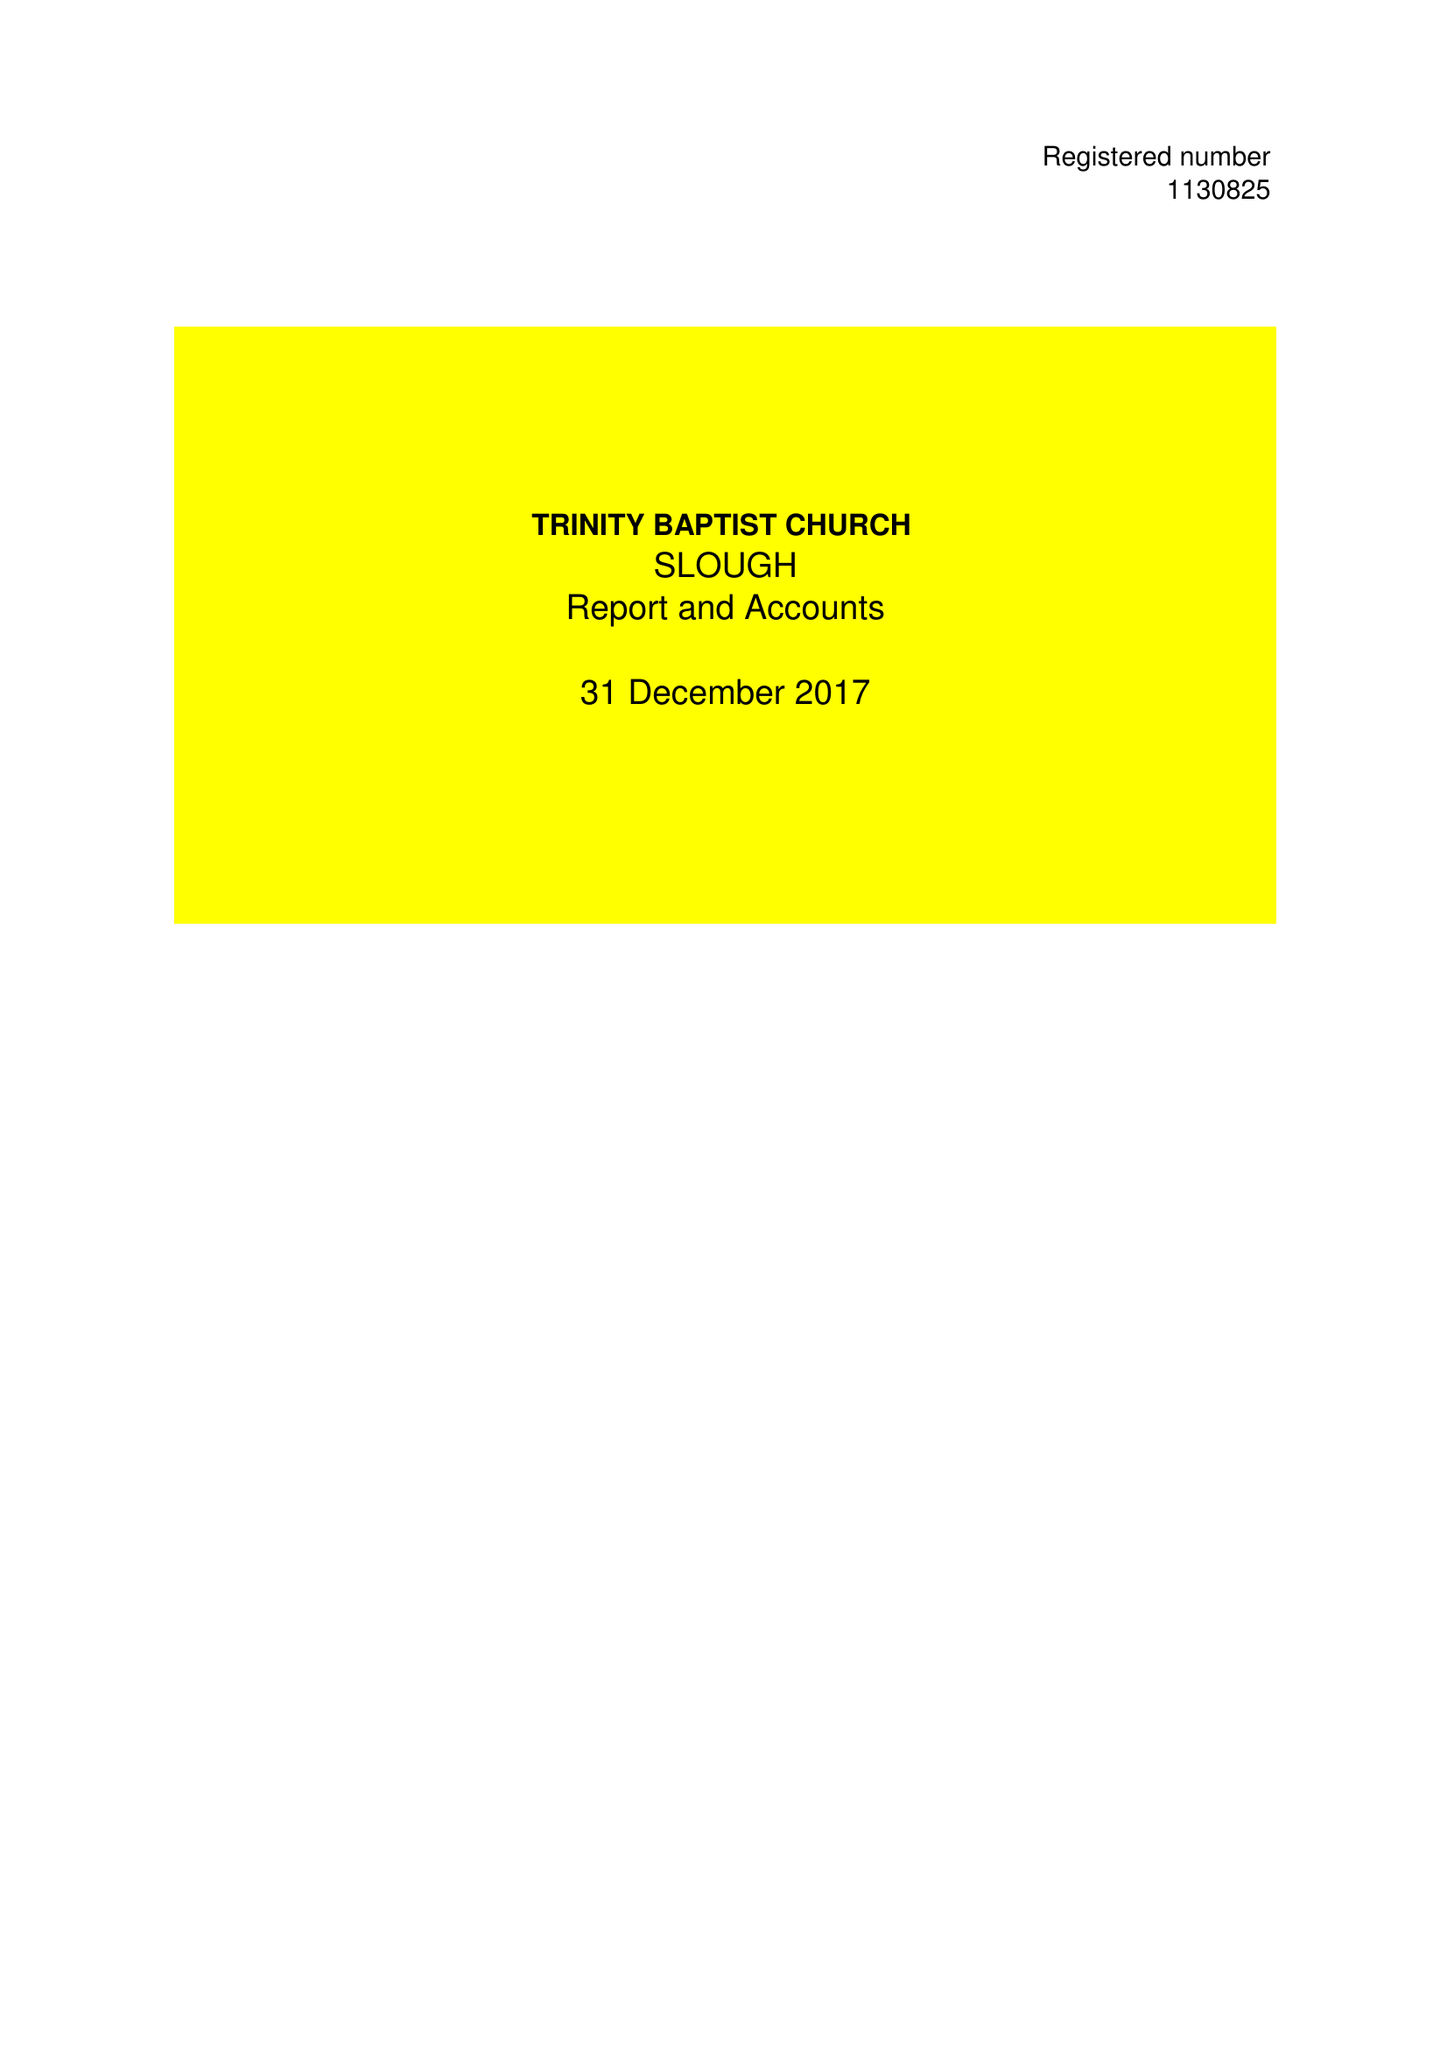What is the value for the income_annually_in_british_pounds?
Answer the question using a single word or phrase. 43575.00 